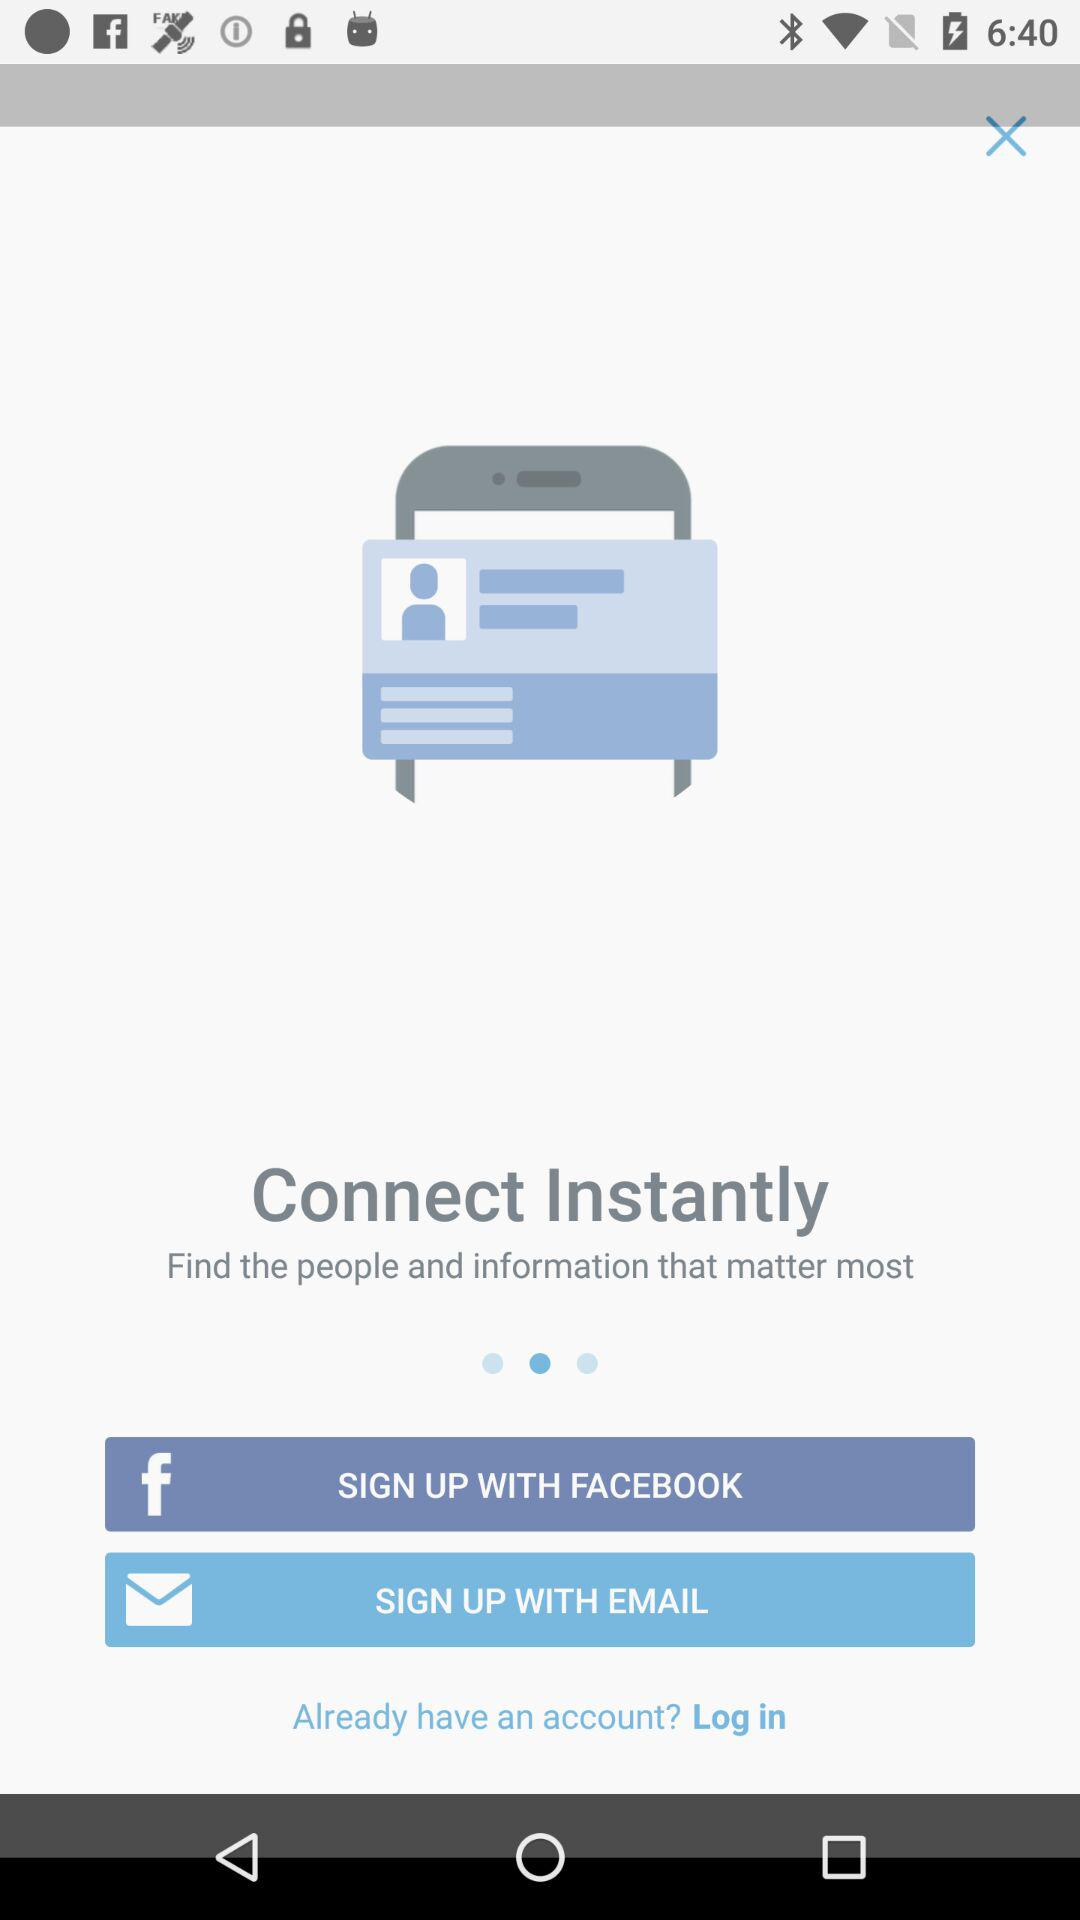Which application can we use for sign up? The applications are "FACEBOOK" and "EMAIL". 